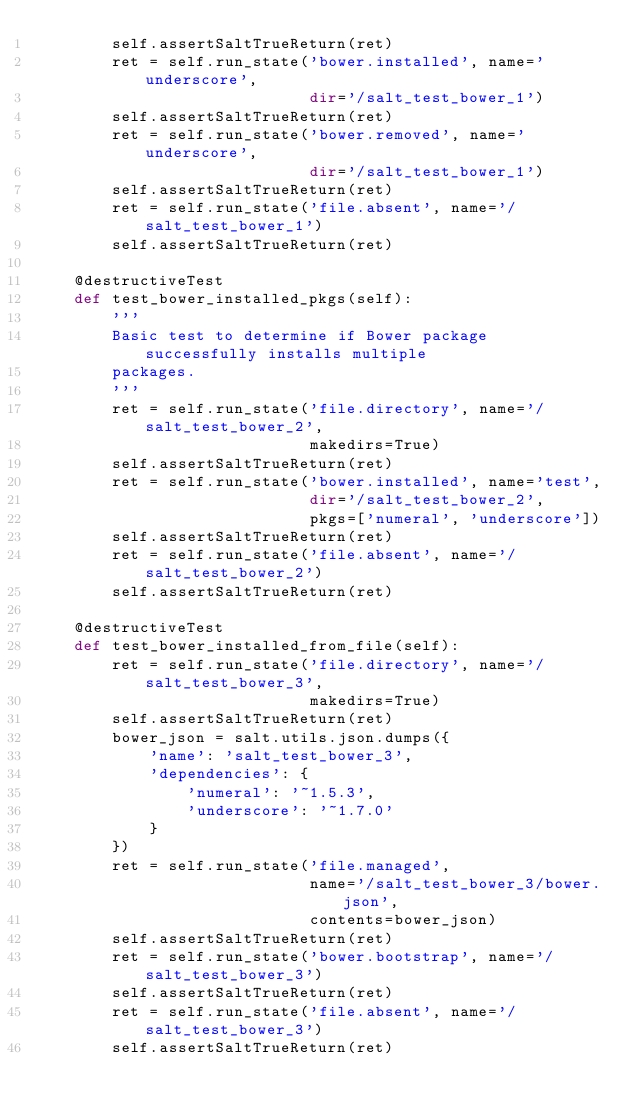Convert code to text. <code><loc_0><loc_0><loc_500><loc_500><_Python_>        self.assertSaltTrueReturn(ret)
        ret = self.run_state('bower.installed', name='underscore',
                             dir='/salt_test_bower_1')
        self.assertSaltTrueReturn(ret)
        ret = self.run_state('bower.removed', name='underscore',
                             dir='/salt_test_bower_1')
        self.assertSaltTrueReturn(ret)
        ret = self.run_state('file.absent', name='/salt_test_bower_1')
        self.assertSaltTrueReturn(ret)

    @destructiveTest
    def test_bower_installed_pkgs(self):
        '''
        Basic test to determine if Bower package successfully installs multiple
        packages.
        '''
        ret = self.run_state('file.directory', name='/salt_test_bower_2',
                             makedirs=True)
        self.assertSaltTrueReturn(ret)
        ret = self.run_state('bower.installed', name='test',
                             dir='/salt_test_bower_2',
                             pkgs=['numeral', 'underscore'])
        self.assertSaltTrueReturn(ret)
        ret = self.run_state('file.absent', name='/salt_test_bower_2')
        self.assertSaltTrueReturn(ret)

    @destructiveTest
    def test_bower_installed_from_file(self):
        ret = self.run_state('file.directory', name='/salt_test_bower_3',
                             makedirs=True)
        self.assertSaltTrueReturn(ret)
        bower_json = salt.utils.json.dumps({
            'name': 'salt_test_bower_3',
            'dependencies': {
                'numeral': '~1.5.3',
                'underscore': '~1.7.0'
            }
        })
        ret = self.run_state('file.managed',
                             name='/salt_test_bower_3/bower.json',
                             contents=bower_json)
        self.assertSaltTrueReturn(ret)
        ret = self.run_state('bower.bootstrap', name='/salt_test_bower_3')
        self.assertSaltTrueReturn(ret)
        ret = self.run_state('file.absent', name='/salt_test_bower_3')
        self.assertSaltTrueReturn(ret)
</code> 